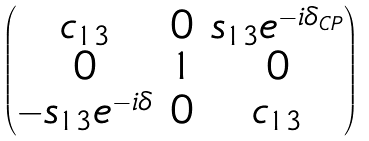Convert formula to latex. <formula><loc_0><loc_0><loc_500><loc_500>\begin{pmatrix} c _ { 1 3 } & 0 & s _ { 1 3 } e ^ { - i \delta _ { C P } } \\ 0 & 1 & 0 \\ - s _ { 1 3 } e ^ { - i \delta } & 0 & c _ { 1 3 } \end{pmatrix}</formula> 